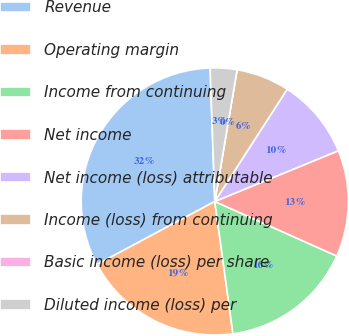Convert chart to OTSL. <chart><loc_0><loc_0><loc_500><loc_500><pie_chart><fcel>Revenue<fcel>Operating margin<fcel>Income from continuing<fcel>Net income<fcel>Net income (loss) attributable<fcel>Income (loss) from continuing<fcel>Basic income (loss) per share<fcel>Diluted income (loss) per<nl><fcel>32.26%<fcel>19.35%<fcel>16.13%<fcel>12.9%<fcel>9.68%<fcel>6.45%<fcel>0.0%<fcel>3.23%<nl></chart> 